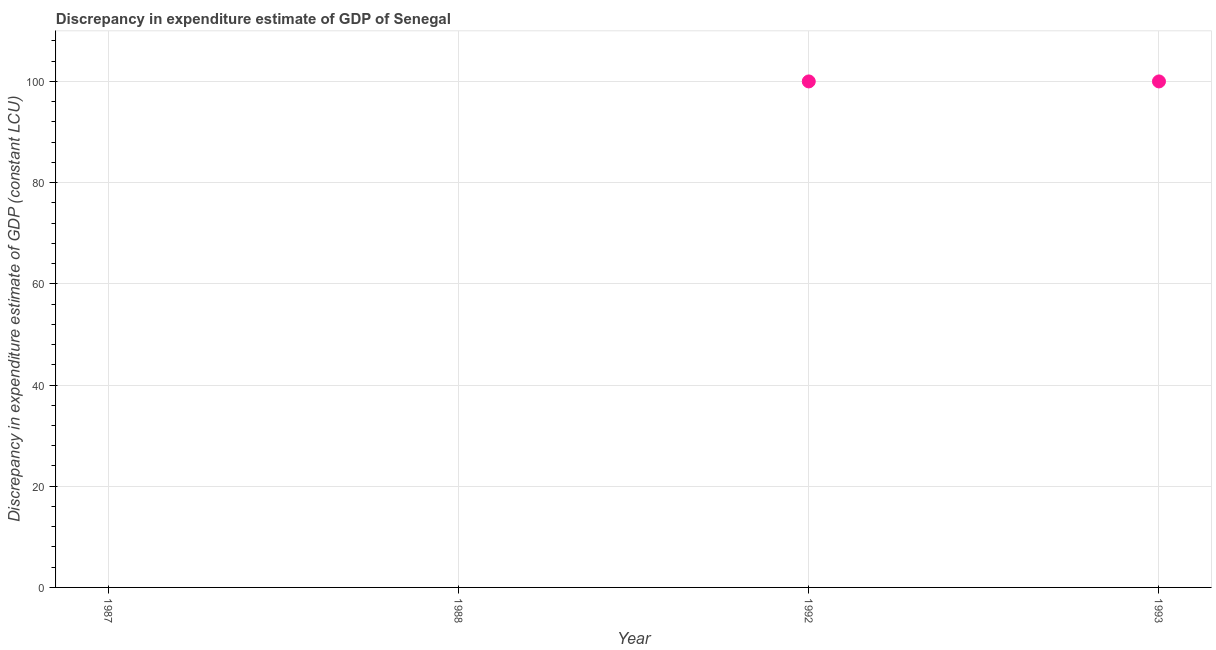What is the discrepancy in expenditure estimate of gdp in 1988?
Offer a terse response. 0. Across all years, what is the maximum discrepancy in expenditure estimate of gdp?
Your response must be concise. 100. In which year was the discrepancy in expenditure estimate of gdp maximum?
Offer a very short reply. 1992. What is the sum of the discrepancy in expenditure estimate of gdp?
Give a very brief answer. 200. What is the average discrepancy in expenditure estimate of gdp per year?
Offer a very short reply. 50. In how many years, is the discrepancy in expenditure estimate of gdp greater than 4 LCU?
Provide a short and direct response. 2. Is the sum of the discrepancy in expenditure estimate of gdp in 1992 and 1993 greater than the maximum discrepancy in expenditure estimate of gdp across all years?
Your answer should be very brief. Yes. What is the difference between the highest and the lowest discrepancy in expenditure estimate of gdp?
Ensure brevity in your answer.  100. How many dotlines are there?
Make the answer very short. 1. How many years are there in the graph?
Your response must be concise. 4. Are the values on the major ticks of Y-axis written in scientific E-notation?
Offer a terse response. No. Does the graph contain grids?
Provide a short and direct response. Yes. What is the title of the graph?
Your answer should be very brief. Discrepancy in expenditure estimate of GDP of Senegal. What is the label or title of the X-axis?
Your response must be concise. Year. What is the label or title of the Y-axis?
Your response must be concise. Discrepancy in expenditure estimate of GDP (constant LCU). What is the Discrepancy in expenditure estimate of GDP (constant LCU) in 1987?
Keep it short and to the point. 0. What is the Discrepancy in expenditure estimate of GDP (constant LCU) in 1993?
Make the answer very short. 100. What is the ratio of the Discrepancy in expenditure estimate of GDP (constant LCU) in 1992 to that in 1993?
Provide a short and direct response. 1. 